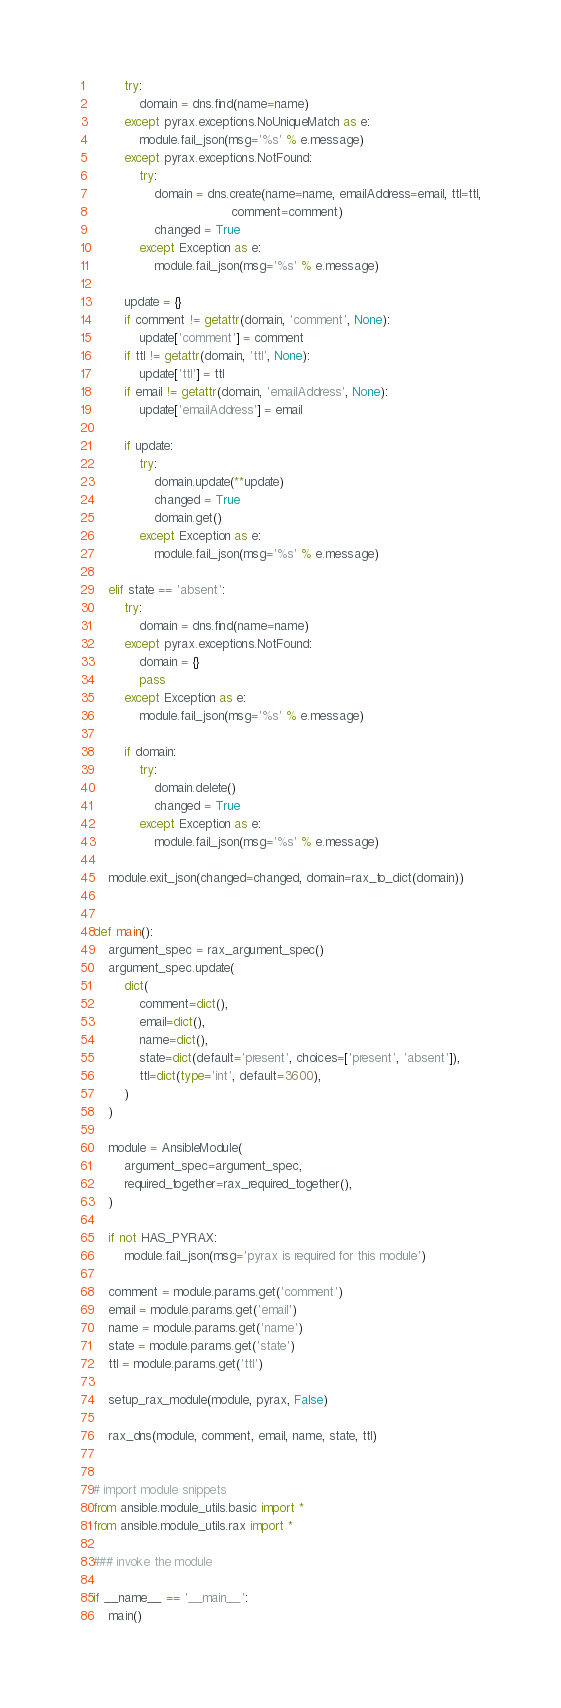Convert code to text. <code><loc_0><loc_0><loc_500><loc_500><_Python_>        try:
            domain = dns.find(name=name)
        except pyrax.exceptions.NoUniqueMatch as e:
            module.fail_json(msg='%s' % e.message)
        except pyrax.exceptions.NotFound:
            try:
                domain = dns.create(name=name, emailAddress=email, ttl=ttl,
                                    comment=comment)
                changed = True
            except Exception as e:
                module.fail_json(msg='%s' % e.message)

        update = {}
        if comment != getattr(domain, 'comment', None):
            update['comment'] = comment
        if ttl != getattr(domain, 'ttl', None):
            update['ttl'] = ttl
        if email != getattr(domain, 'emailAddress', None):
            update['emailAddress'] = email

        if update:
            try:
                domain.update(**update)
                changed = True
                domain.get()
            except Exception as e:
                module.fail_json(msg='%s' % e.message)

    elif state == 'absent':
        try:
            domain = dns.find(name=name)
        except pyrax.exceptions.NotFound:
            domain = {}
            pass
        except Exception as e:
            module.fail_json(msg='%s' % e.message)

        if domain:
            try:
                domain.delete()
                changed = True
            except Exception as e:
                module.fail_json(msg='%s' % e.message)

    module.exit_json(changed=changed, domain=rax_to_dict(domain))


def main():
    argument_spec = rax_argument_spec()
    argument_spec.update(
        dict(
            comment=dict(),
            email=dict(),
            name=dict(),
            state=dict(default='present', choices=['present', 'absent']),
            ttl=dict(type='int', default=3600),
        )
    )

    module = AnsibleModule(
        argument_spec=argument_spec,
        required_together=rax_required_together(),
    )

    if not HAS_PYRAX:
        module.fail_json(msg='pyrax is required for this module')

    comment = module.params.get('comment')
    email = module.params.get('email')
    name = module.params.get('name')
    state = module.params.get('state')
    ttl = module.params.get('ttl')

    setup_rax_module(module, pyrax, False)

    rax_dns(module, comment, email, name, state, ttl)


# import module snippets
from ansible.module_utils.basic import *
from ansible.module_utils.rax import *

### invoke the module

if __name__ == '__main__':
    main()
</code> 